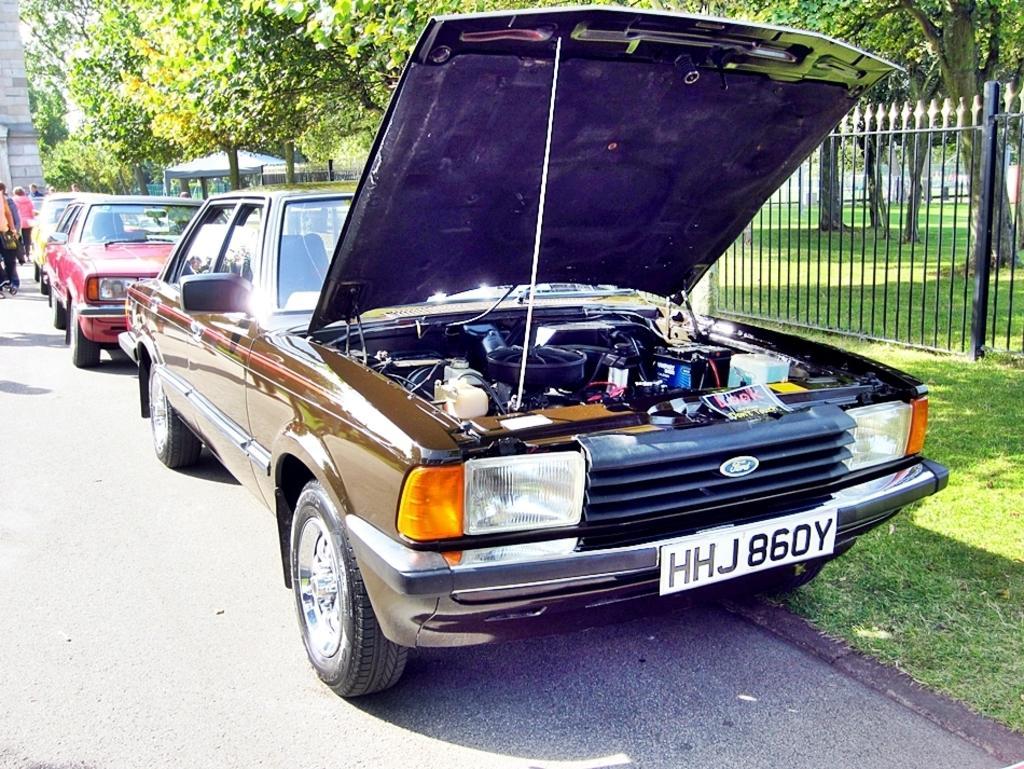Please provide a concise description of this image. In this picture there are vehicles on the road. On the left side of the image there are group of people walking on the road. At the back there is a building and there is a tent. On the right side of the image there is a railing and there are trees. At the bottom there is grass and there is a road. 